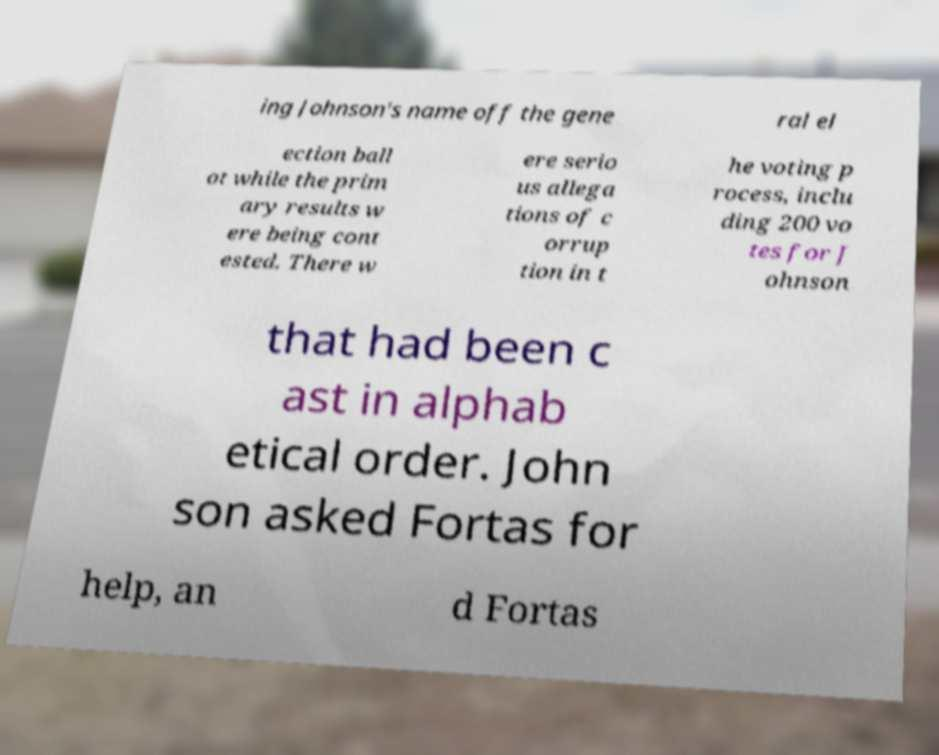There's text embedded in this image that I need extracted. Can you transcribe it verbatim? ing Johnson's name off the gene ral el ection ball ot while the prim ary results w ere being cont ested. There w ere serio us allega tions of c orrup tion in t he voting p rocess, inclu ding 200 vo tes for J ohnson that had been c ast in alphab etical order. John son asked Fortas for help, an d Fortas 